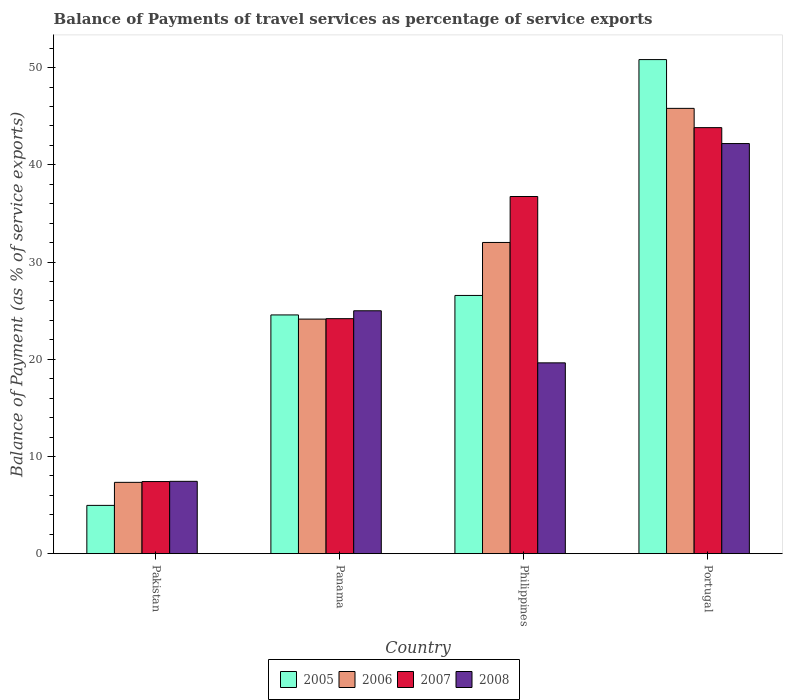How many groups of bars are there?
Your response must be concise. 4. Are the number of bars per tick equal to the number of legend labels?
Make the answer very short. Yes. What is the label of the 2nd group of bars from the left?
Provide a succinct answer. Panama. What is the balance of payments of travel services in 2006 in Panama?
Your answer should be very brief. 24.13. Across all countries, what is the maximum balance of payments of travel services in 2006?
Ensure brevity in your answer.  45.81. Across all countries, what is the minimum balance of payments of travel services in 2005?
Offer a very short reply. 4.97. In which country was the balance of payments of travel services in 2007 minimum?
Provide a short and direct response. Pakistan. What is the total balance of payments of travel services in 2007 in the graph?
Ensure brevity in your answer.  112.17. What is the difference between the balance of payments of travel services in 2008 in Philippines and that in Portugal?
Provide a succinct answer. -22.56. What is the difference between the balance of payments of travel services in 2006 in Pakistan and the balance of payments of travel services in 2007 in Philippines?
Offer a terse response. -29.41. What is the average balance of payments of travel services in 2008 per country?
Make the answer very short. 23.56. What is the difference between the balance of payments of travel services of/in 2008 and balance of payments of travel services of/in 2006 in Portugal?
Provide a succinct answer. -3.62. In how many countries, is the balance of payments of travel services in 2007 greater than 20 %?
Your answer should be very brief. 3. What is the ratio of the balance of payments of travel services in 2005 in Pakistan to that in Panama?
Your answer should be compact. 0.2. Is the balance of payments of travel services in 2006 in Pakistan less than that in Portugal?
Provide a succinct answer. Yes. Is the difference between the balance of payments of travel services in 2008 in Panama and Philippines greater than the difference between the balance of payments of travel services in 2006 in Panama and Philippines?
Make the answer very short. Yes. What is the difference between the highest and the second highest balance of payments of travel services in 2006?
Keep it short and to the point. 7.88. What is the difference between the highest and the lowest balance of payments of travel services in 2007?
Provide a succinct answer. 36.41. Is the sum of the balance of payments of travel services in 2008 in Philippines and Portugal greater than the maximum balance of payments of travel services in 2006 across all countries?
Keep it short and to the point. Yes. What does the 1st bar from the right in Philippines represents?
Provide a short and direct response. 2008. How many bars are there?
Give a very brief answer. 16. Are all the bars in the graph horizontal?
Offer a very short reply. No. How many countries are there in the graph?
Your answer should be compact. 4. How many legend labels are there?
Offer a terse response. 4. How are the legend labels stacked?
Ensure brevity in your answer.  Horizontal. What is the title of the graph?
Your answer should be compact. Balance of Payments of travel services as percentage of service exports. Does "2015" appear as one of the legend labels in the graph?
Offer a very short reply. No. What is the label or title of the X-axis?
Offer a terse response. Country. What is the label or title of the Y-axis?
Your answer should be compact. Balance of Payment (as % of service exports). What is the Balance of Payment (as % of service exports) of 2005 in Pakistan?
Keep it short and to the point. 4.97. What is the Balance of Payment (as % of service exports) of 2006 in Pakistan?
Keep it short and to the point. 7.34. What is the Balance of Payment (as % of service exports) in 2007 in Pakistan?
Make the answer very short. 7.42. What is the Balance of Payment (as % of service exports) of 2008 in Pakistan?
Make the answer very short. 7.44. What is the Balance of Payment (as % of service exports) of 2005 in Panama?
Provide a short and direct response. 24.56. What is the Balance of Payment (as % of service exports) in 2006 in Panama?
Your response must be concise. 24.13. What is the Balance of Payment (as % of service exports) in 2007 in Panama?
Provide a short and direct response. 24.18. What is the Balance of Payment (as % of service exports) of 2008 in Panama?
Offer a terse response. 24.99. What is the Balance of Payment (as % of service exports) of 2005 in Philippines?
Ensure brevity in your answer.  26.56. What is the Balance of Payment (as % of service exports) in 2006 in Philippines?
Your answer should be very brief. 32.02. What is the Balance of Payment (as % of service exports) of 2007 in Philippines?
Provide a succinct answer. 36.74. What is the Balance of Payment (as % of service exports) in 2008 in Philippines?
Your response must be concise. 19.63. What is the Balance of Payment (as % of service exports) of 2005 in Portugal?
Keep it short and to the point. 50.83. What is the Balance of Payment (as % of service exports) in 2006 in Portugal?
Give a very brief answer. 45.81. What is the Balance of Payment (as % of service exports) of 2007 in Portugal?
Offer a very short reply. 43.83. What is the Balance of Payment (as % of service exports) in 2008 in Portugal?
Your answer should be very brief. 42.19. Across all countries, what is the maximum Balance of Payment (as % of service exports) of 2005?
Offer a terse response. 50.83. Across all countries, what is the maximum Balance of Payment (as % of service exports) of 2006?
Ensure brevity in your answer.  45.81. Across all countries, what is the maximum Balance of Payment (as % of service exports) of 2007?
Your response must be concise. 43.83. Across all countries, what is the maximum Balance of Payment (as % of service exports) of 2008?
Offer a terse response. 42.19. Across all countries, what is the minimum Balance of Payment (as % of service exports) of 2005?
Make the answer very short. 4.97. Across all countries, what is the minimum Balance of Payment (as % of service exports) in 2006?
Offer a very short reply. 7.34. Across all countries, what is the minimum Balance of Payment (as % of service exports) in 2007?
Make the answer very short. 7.42. Across all countries, what is the minimum Balance of Payment (as % of service exports) of 2008?
Keep it short and to the point. 7.44. What is the total Balance of Payment (as % of service exports) in 2005 in the graph?
Offer a very short reply. 106.92. What is the total Balance of Payment (as % of service exports) in 2006 in the graph?
Your answer should be compact. 109.29. What is the total Balance of Payment (as % of service exports) of 2007 in the graph?
Provide a short and direct response. 112.17. What is the total Balance of Payment (as % of service exports) of 2008 in the graph?
Offer a very short reply. 94.25. What is the difference between the Balance of Payment (as % of service exports) of 2005 in Pakistan and that in Panama?
Offer a terse response. -19.59. What is the difference between the Balance of Payment (as % of service exports) in 2006 in Pakistan and that in Panama?
Provide a succinct answer. -16.79. What is the difference between the Balance of Payment (as % of service exports) in 2007 in Pakistan and that in Panama?
Your answer should be compact. -16.76. What is the difference between the Balance of Payment (as % of service exports) in 2008 in Pakistan and that in Panama?
Make the answer very short. -17.55. What is the difference between the Balance of Payment (as % of service exports) of 2005 in Pakistan and that in Philippines?
Offer a terse response. -21.6. What is the difference between the Balance of Payment (as % of service exports) of 2006 in Pakistan and that in Philippines?
Your response must be concise. -24.68. What is the difference between the Balance of Payment (as % of service exports) in 2007 in Pakistan and that in Philippines?
Your answer should be very brief. -29.33. What is the difference between the Balance of Payment (as % of service exports) of 2008 in Pakistan and that in Philippines?
Your answer should be very brief. -12.19. What is the difference between the Balance of Payment (as % of service exports) in 2005 in Pakistan and that in Portugal?
Your answer should be compact. -45.86. What is the difference between the Balance of Payment (as % of service exports) in 2006 in Pakistan and that in Portugal?
Your answer should be very brief. -38.47. What is the difference between the Balance of Payment (as % of service exports) of 2007 in Pakistan and that in Portugal?
Make the answer very short. -36.41. What is the difference between the Balance of Payment (as % of service exports) in 2008 in Pakistan and that in Portugal?
Ensure brevity in your answer.  -34.75. What is the difference between the Balance of Payment (as % of service exports) of 2005 in Panama and that in Philippines?
Offer a very short reply. -2. What is the difference between the Balance of Payment (as % of service exports) in 2006 in Panama and that in Philippines?
Your answer should be very brief. -7.88. What is the difference between the Balance of Payment (as % of service exports) in 2007 in Panama and that in Philippines?
Provide a short and direct response. -12.57. What is the difference between the Balance of Payment (as % of service exports) of 2008 in Panama and that in Philippines?
Ensure brevity in your answer.  5.36. What is the difference between the Balance of Payment (as % of service exports) of 2005 in Panama and that in Portugal?
Ensure brevity in your answer.  -26.27. What is the difference between the Balance of Payment (as % of service exports) of 2006 in Panama and that in Portugal?
Give a very brief answer. -21.68. What is the difference between the Balance of Payment (as % of service exports) in 2007 in Panama and that in Portugal?
Your response must be concise. -19.65. What is the difference between the Balance of Payment (as % of service exports) in 2008 in Panama and that in Portugal?
Your answer should be compact. -17.2. What is the difference between the Balance of Payment (as % of service exports) in 2005 in Philippines and that in Portugal?
Your answer should be very brief. -24.27. What is the difference between the Balance of Payment (as % of service exports) of 2006 in Philippines and that in Portugal?
Provide a short and direct response. -13.8. What is the difference between the Balance of Payment (as % of service exports) in 2007 in Philippines and that in Portugal?
Ensure brevity in your answer.  -7.09. What is the difference between the Balance of Payment (as % of service exports) in 2008 in Philippines and that in Portugal?
Make the answer very short. -22.56. What is the difference between the Balance of Payment (as % of service exports) of 2005 in Pakistan and the Balance of Payment (as % of service exports) of 2006 in Panama?
Ensure brevity in your answer.  -19.16. What is the difference between the Balance of Payment (as % of service exports) in 2005 in Pakistan and the Balance of Payment (as % of service exports) in 2007 in Panama?
Ensure brevity in your answer.  -19.21. What is the difference between the Balance of Payment (as % of service exports) in 2005 in Pakistan and the Balance of Payment (as % of service exports) in 2008 in Panama?
Your answer should be very brief. -20.02. What is the difference between the Balance of Payment (as % of service exports) of 2006 in Pakistan and the Balance of Payment (as % of service exports) of 2007 in Panama?
Provide a short and direct response. -16.84. What is the difference between the Balance of Payment (as % of service exports) of 2006 in Pakistan and the Balance of Payment (as % of service exports) of 2008 in Panama?
Your answer should be very brief. -17.65. What is the difference between the Balance of Payment (as % of service exports) in 2007 in Pakistan and the Balance of Payment (as % of service exports) in 2008 in Panama?
Make the answer very short. -17.57. What is the difference between the Balance of Payment (as % of service exports) of 2005 in Pakistan and the Balance of Payment (as % of service exports) of 2006 in Philippines?
Offer a very short reply. -27.05. What is the difference between the Balance of Payment (as % of service exports) of 2005 in Pakistan and the Balance of Payment (as % of service exports) of 2007 in Philippines?
Your response must be concise. -31.78. What is the difference between the Balance of Payment (as % of service exports) of 2005 in Pakistan and the Balance of Payment (as % of service exports) of 2008 in Philippines?
Your answer should be compact. -14.66. What is the difference between the Balance of Payment (as % of service exports) of 2006 in Pakistan and the Balance of Payment (as % of service exports) of 2007 in Philippines?
Offer a terse response. -29.41. What is the difference between the Balance of Payment (as % of service exports) in 2006 in Pakistan and the Balance of Payment (as % of service exports) in 2008 in Philippines?
Offer a very short reply. -12.29. What is the difference between the Balance of Payment (as % of service exports) of 2007 in Pakistan and the Balance of Payment (as % of service exports) of 2008 in Philippines?
Your response must be concise. -12.21. What is the difference between the Balance of Payment (as % of service exports) of 2005 in Pakistan and the Balance of Payment (as % of service exports) of 2006 in Portugal?
Your answer should be compact. -40.84. What is the difference between the Balance of Payment (as % of service exports) of 2005 in Pakistan and the Balance of Payment (as % of service exports) of 2007 in Portugal?
Make the answer very short. -38.86. What is the difference between the Balance of Payment (as % of service exports) of 2005 in Pakistan and the Balance of Payment (as % of service exports) of 2008 in Portugal?
Ensure brevity in your answer.  -37.22. What is the difference between the Balance of Payment (as % of service exports) in 2006 in Pakistan and the Balance of Payment (as % of service exports) in 2007 in Portugal?
Ensure brevity in your answer.  -36.49. What is the difference between the Balance of Payment (as % of service exports) in 2006 in Pakistan and the Balance of Payment (as % of service exports) in 2008 in Portugal?
Offer a terse response. -34.85. What is the difference between the Balance of Payment (as % of service exports) of 2007 in Pakistan and the Balance of Payment (as % of service exports) of 2008 in Portugal?
Provide a short and direct response. -34.77. What is the difference between the Balance of Payment (as % of service exports) in 2005 in Panama and the Balance of Payment (as % of service exports) in 2006 in Philippines?
Offer a terse response. -7.46. What is the difference between the Balance of Payment (as % of service exports) of 2005 in Panama and the Balance of Payment (as % of service exports) of 2007 in Philippines?
Your answer should be compact. -12.18. What is the difference between the Balance of Payment (as % of service exports) of 2005 in Panama and the Balance of Payment (as % of service exports) of 2008 in Philippines?
Provide a short and direct response. 4.93. What is the difference between the Balance of Payment (as % of service exports) in 2006 in Panama and the Balance of Payment (as % of service exports) in 2007 in Philippines?
Offer a terse response. -12.61. What is the difference between the Balance of Payment (as % of service exports) of 2006 in Panama and the Balance of Payment (as % of service exports) of 2008 in Philippines?
Keep it short and to the point. 4.5. What is the difference between the Balance of Payment (as % of service exports) of 2007 in Panama and the Balance of Payment (as % of service exports) of 2008 in Philippines?
Keep it short and to the point. 4.55. What is the difference between the Balance of Payment (as % of service exports) of 2005 in Panama and the Balance of Payment (as % of service exports) of 2006 in Portugal?
Offer a very short reply. -21.25. What is the difference between the Balance of Payment (as % of service exports) of 2005 in Panama and the Balance of Payment (as % of service exports) of 2007 in Portugal?
Offer a terse response. -19.27. What is the difference between the Balance of Payment (as % of service exports) in 2005 in Panama and the Balance of Payment (as % of service exports) in 2008 in Portugal?
Ensure brevity in your answer.  -17.63. What is the difference between the Balance of Payment (as % of service exports) of 2006 in Panama and the Balance of Payment (as % of service exports) of 2007 in Portugal?
Give a very brief answer. -19.7. What is the difference between the Balance of Payment (as % of service exports) in 2006 in Panama and the Balance of Payment (as % of service exports) in 2008 in Portugal?
Give a very brief answer. -18.06. What is the difference between the Balance of Payment (as % of service exports) of 2007 in Panama and the Balance of Payment (as % of service exports) of 2008 in Portugal?
Provide a short and direct response. -18.02. What is the difference between the Balance of Payment (as % of service exports) of 2005 in Philippines and the Balance of Payment (as % of service exports) of 2006 in Portugal?
Offer a very short reply. -19.25. What is the difference between the Balance of Payment (as % of service exports) of 2005 in Philippines and the Balance of Payment (as % of service exports) of 2007 in Portugal?
Keep it short and to the point. -17.27. What is the difference between the Balance of Payment (as % of service exports) in 2005 in Philippines and the Balance of Payment (as % of service exports) in 2008 in Portugal?
Offer a very short reply. -15.63. What is the difference between the Balance of Payment (as % of service exports) in 2006 in Philippines and the Balance of Payment (as % of service exports) in 2007 in Portugal?
Ensure brevity in your answer.  -11.81. What is the difference between the Balance of Payment (as % of service exports) in 2006 in Philippines and the Balance of Payment (as % of service exports) in 2008 in Portugal?
Your answer should be very brief. -10.18. What is the difference between the Balance of Payment (as % of service exports) in 2007 in Philippines and the Balance of Payment (as % of service exports) in 2008 in Portugal?
Provide a short and direct response. -5.45. What is the average Balance of Payment (as % of service exports) of 2005 per country?
Make the answer very short. 26.73. What is the average Balance of Payment (as % of service exports) in 2006 per country?
Your answer should be compact. 27.32. What is the average Balance of Payment (as % of service exports) of 2007 per country?
Ensure brevity in your answer.  28.04. What is the average Balance of Payment (as % of service exports) in 2008 per country?
Give a very brief answer. 23.56. What is the difference between the Balance of Payment (as % of service exports) of 2005 and Balance of Payment (as % of service exports) of 2006 in Pakistan?
Give a very brief answer. -2.37. What is the difference between the Balance of Payment (as % of service exports) in 2005 and Balance of Payment (as % of service exports) in 2007 in Pakistan?
Your answer should be very brief. -2.45. What is the difference between the Balance of Payment (as % of service exports) in 2005 and Balance of Payment (as % of service exports) in 2008 in Pakistan?
Provide a succinct answer. -2.47. What is the difference between the Balance of Payment (as % of service exports) of 2006 and Balance of Payment (as % of service exports) of 2007 in Pakistan?
Your response must be concise. -0.08. What is the difference between the Balance of Payment (as % of service exports) in 2006 and Balance of Payment (as % of service exports) in 2008 in Pakistan?
Ensure brevity in your answer.  -0.1. What is the difference between the Balance of Payment (as % of service exports) of 2007 and Balance of Payment (as % of service exports) of 2008 in Pakistan?
Give a very brief answer. -0.02. What is the difference between the Balance of Payment (as % of service exports) of 2005 and Balance of Payment (as % of service exports) of 2006 in Panama?
Provide a succinct answer. 0.43. What is the difference between the Balance of Payment (as % of service exports) of 2005 and Balance of Payment (as % of service exports) of 2007 in Panama?
Your response must be concise. 0.38. What is the difference between the Balance of Payment (as % of service exports) in 2005 and Balance of Payment (as % of service exports) in 2008 in Panama?
Keep it short and to the point. -0.43. What is the difference between the Balance of Payment (as % of service exports) of 2006 and Balance of Payment (as % of service exports) of 2007 in Panama?
Give a very brief answer. -0.04. What is the difference between the Balance of Payment (as % of service exports) of 2006 and Balance of Payment (as % of service exports) of 2008 in Panama?
Your answer should be compact. -0.86. What is the difference between the Balance of Payment (as % of service exports) of 2007 and Balance of Payment (as % of service exports) of 2008 in Panama?
Offer a very short reply. -0.81. What is the difference between the Balance of Payment (as % of service exports) of 2005 and Balance of Payment (as % of service exports) of 2006 in Philippines?
Make the answer very short. -5.45. What is the difference between the Balance of Payment (as % of service exports) of 2005 and Balance of Payment (as % of service exports) of 2007 in Philippines?
Keep it short and to the point. -10.18. What is the difference between the Balance of Payment (as % of service exports) of 2005 and Balance of Payment (as % of service exports) of 2008 in Philippines?
Give a very brief answer. 6.93. What is the difference between the Balance of Payment (as % of service exports) in 2006 and Balance of Payment (as % of service exports) in 2007 in Philippines?
Make the answer very short. -4.73. What is the difference between the Balance of Payment (as % of service exports) of 2006 and Balance of Payment (as % of service exports) of 2008 in Philippines?
Keep it short and to the point. 12.39. What is the difference between the Balance of Payment (as % of service exports) in 2007 and Balance of Payment (as % of service exports) in 2008 in Philippines?
Your response must be concise. 17.11. What is the difference between the Balance of Payment (as % of service exports) in 2005 and Balance of Payment (as % of service exports) in 2006 in Portugal?
Offer a terse response. 5.02. What is the difference between the Balance of Payment (as % of service exports) in 2005 and Balance of Payment (as % of service exports) in 2007 in Portugal?
Your answer should be very brief. 7. What is the difference between the Balance of Payment (as % of service exports) in 2005 and Balance of Payment (as % of service exports) in 2008 in Portugal?
Your answer should be very brief. 8.64. What is the difference between the Balance of Payment (as % of service exports) in 2006 and Balance of Payment (as % of service exports) in 2007 in Portugal?
Your answer should be compact. 1.98. What is the difference between the Balance of Payment (as % of service exports) of 2006 and Balance of Payment (as % of service exports) of 2008 in Portugal?
Your response must be concise. 3.62. What is the difference between the Balance of Payment (as % of service exports) in 2007 and Balance of Payment (as % of service exports) in 2008 in Portugal?
Provide a succinct answer. 1.64. What is the ratio of the Balance of Payment (as % of service exports) in 2005 in Pakistan to that in Panama?
Ensure brevity in your answer.  0.2. What is the ratio of the Balance of Payment (as % of service exports) in 2006 in Pakistan to that in Panama?
Offer a very short reply. 0.3. What is the ratio of the Balance of Payment (as % of service exports) in 2007 in Pakistan to that in Panama?
Keep it short and to the point. 0.31. What is the ratio of the Balance of Payment (as % of service exports) of 2008 in Pakistan to that in Panama?
Provide a short and direct response. 0.3. What is the ratio of the Balance of Payment (as % of service exports) in 2005 in Pakistan to that in Philippines?
Your response must be concise. 0.19. What is the ratio of the Balance of Payment (as % of service exports) of 2006 in Pakistan to that in Philippines?
Provide a succinct answer. 0.23. What is the ratio of the Balance of Payment (as % of service exports) in 2007 in Pakistan to that in Philippines?
Provide a succinct answer. 0.2. What is the ratio of the Balance of Payment (as % of service exports) in 2008 in Pakistan to that in Philippines?
Your answer should be compact. 0.38. What is the ratio of the Balance of Payment (as % of service exports) of 2005 in Pakistan to that in Portugal?
Your answer should be compact. 0.1. What is the ratio of the Balance of Payment (as % of service exports) of 2006 in Pakistan to that in Portugal?
Offer a terse response. 0.16. What is the ratio of the Balance of Payment (as % of service exports) of 2007 in Pakistan to that in Portugal?
Give a very brief answer. 0.17. What is the ratio of the Balance of Payment (as % of service exports) in 2008 in Pakistan to that in Portugal?
Your response must be concise. 0.18. What is the ratio of the Balance of Payment (as % of service exports) in 2005 in Panama to that in Philippines?
Offer a very short reply. 0.92. What is the ratio of the Balance of Payment (as % of service exports) of 2006 in Panama to that in Philippines?
Give a very brief answer. 0.75. What is the ratio of the Balance of Payment (as % of service exports) of 2007 in Panama to that in Philippines?
Keep it short and to the point. 0.66. What is the ratio of the Balance of Payment (as % of service exports) in 2008 in Panama to that in Philippines?
Provide a short and direct response. 1.27. What is the ratio of the Balance of Payment (as % of service exports) in 2005 in Panama to that in Portugal?
Provide a succinct answer. 0.48. What is the ratio of the Balance of Payment (as % of service exports) in 2006 in Panama to that in Portugal?
Ensure brevity in your answer.  0.53. What is the ratio of the Balance of Payment (as % of service exports) of 2007 in Panama to that in Portugal?
Offer a very short reply. 0.55. What is the ratio of the Balance of Payment (as % of service exports) of 2008 in Panama to that in Portugal?
Provide a succinct answer. 0.59. What is the ratio of the Balance of Payment (as % of service exports) in 2005 in Philippines to that in Portugal?
Offer a very short reply. 0.52. What is the ratio of the Balance of Payment (as % of service exports) of 2006 in Philippines to that in Portugal?
Your answer should be compact. 0.7. What is the ratio of the Balance of Payment (as % of service exports) of 2007 in Philippines to that in Portugal?
Make the answer very short. 0.84. What is the ratio of the Balance of Payment (as % of service exports) of 2008 in Philippines to that in Portugal?
Keep it short and to the point. 0.47. What is the difference between the highest and the second highest Balance of Payment (as % of service exports) of 2005?
Offer a terse response. 24.27. What is the difference between the highest and the second highest Balance of Payment (as % of service exports) of 2006?
Provide a succinct answer. 13.8. What is the difference between the highest and the second highest Balance of Payment (as % of service exports) of 2007?
Give a very brief answer. 7.09. What is the difference between the highest and the second highest Balance of Payment (as % of service exports) of 2008?
Your response must be concise. 17.2. What is the difference between the highest and the lowest Balance of Payment (as % of service exports) in 2005?
Provide a succinct answer. 45.86. What is the difference between the highest and the lowest Balance of Payment (as % of service exports) in 2006?
Your answer should be very brief. 38.47. What is the difference between the highest and the lowest Balance of Payment (as % of service exports) in 2007?
Provide a short and direct response. 36.41. What is the difference between the highest and the lowest Balance of Payment (as % of service exports) of 2008?
Your answer should be very brief. 34.75. 